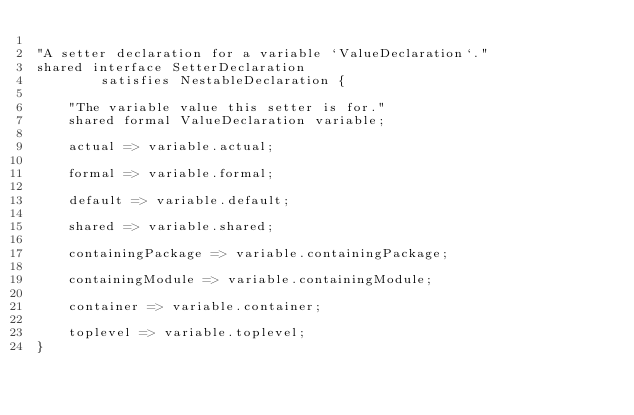Convert code to text. <code><loc_0><loc_0><loc_500><loc_500><_Ceylon_>
"A setter declaration for a variable `ValueDeclaration`."
shared interface SetterDeclaration
        satisfies NestableDeclaration {

    "The variable value this setter is for."
    shared formal ValueDeclaration variable;

    actual => variable.actual;
    
    formal => variable.formal;

    default => variable.default;
    
    shared => variable.shared;

    containingPackage => variable.containingPackage;
    
    containingModule => variable.containingModule;
    
    container => variable.container;

    toplevel => variable.toplevel;
}
</code> 